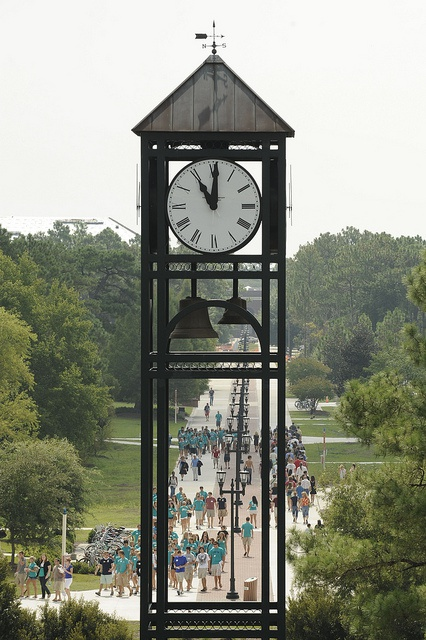Describe the objects in this image and their specific colors. I can see people in white, black, gray, darkgray, and lightgray tones, clock in white, darkgray, black, gray, and lightgray tones, people in white, black, olive, and gray tones, people in white, darkgray, black, tan, and gray tones, and people in white, gray, and teal tones in this image. 